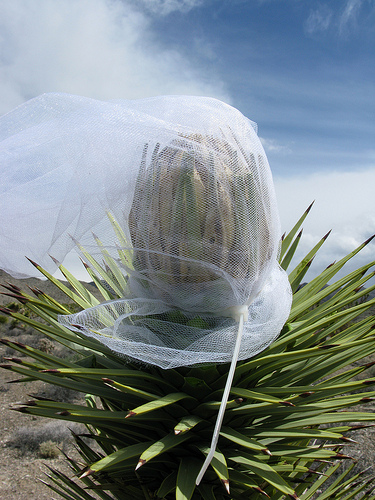<image>
Is there a sky behind the plant? Yes. From this viewpoint, the sky is positioned behind the plant, with the plant partially or fully occluding the sky. 